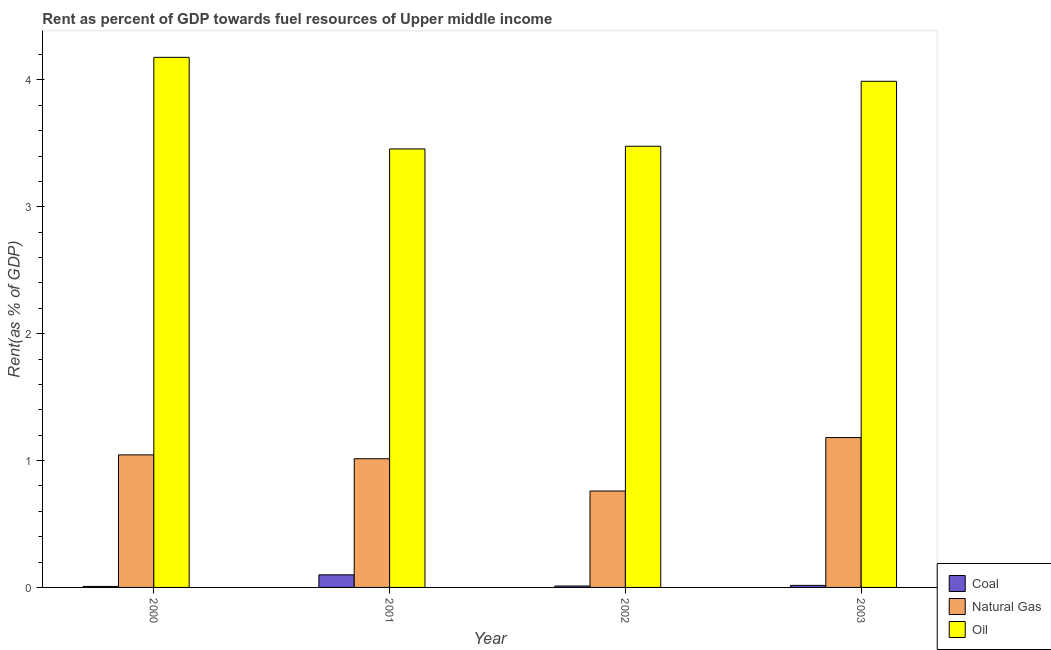How many groups of bars are there?
Ensure brevity in your answer.  4. Are the number of bars per tick equal to the number of legend labels?
Provide a short and direct response. Yes. Are the number of bars on each tick of the X-axis equal?
Provide a succinct answer. Yes. How many bars are there on the 1st tick from the left?
Your answer should be compact. 3. How many bars are there on the 1st tick from the right?
Make the answer very short. 3. What is the label of the 2nd group of bars from the left?
Provide a short and direct response. 2001. In how many cases, is the number of bars for a given year not equal to the number of legend labels?
Make the answer very short. 0. What is the rent towards coal in 2001?
Give a very brief answer. 0.1. Across all years, what is the maximum rent towards oil?
Your response must be concise. 4.18. Across all years, what is the minimum rent towards oil?
Your response must be concise. 3.46. In which year was the rent towards coal maximum?
Make the answer very short. 2001. What is the total rent towards oil in the graph?
Offer a terse response. 15.1. What is the difference between the rent towards oil in 2001 and that in 2003?
Your answer should be very brief. -0.53. What is the difference between the rent towards natural gas in 2003 and the rent towards oil in 2002?
Ensure brevity in your answer.  0.42. What is the average rent towards coal per year?
Give a very brief answer. 0.03. In the year 2002, what is the difference between the rent towards natural gas and rent towards coal?
Your answer should be very brief. 0. What is the ratio of the rent towards coal in 2000 to that in 2002?
Offer a terse response. 0.72. What is the difference between the highest and the second highest rent towards oil?
Your response must be concise. 0.19. What is the difference between the highest and the lowest rent towards oil?
Offer a very short reply. 0.72. What does the 1st bar from the left in 2002 represents?
Keep it short and to the point. Coal. What does the 1st bar from the right in 2000 represents?
Give a very brief answer. Oil. Is it the case that in every year, the sum of the rent towards coal and rent towards natural gas is greater than the rent towards oil?
Provide a succinct answer. No. Are all the bars in the graph horizontal?
Make the answer very short. No. How many years are there in the graph?
Keep it short and to the point. 4. What is the difference between two consecutive major ticks on the Y-axis?
Offer a very short reply. 1. Are the values on the major ticks of Y-axis written in scientific E-notation?
Provide a succinct answer. No. Does the graph contain any zero values?
Offer a terse response. No. Does the graph contain grids?
Offer a very short reply. No. Where does the legend appear in the graph?
Ensure brevity in your answer.  Bottom right. How are the legend labels stacked?
Your response must be concise. Vertical. What is the title of the graph?
Provide a short and direct response. Rent as percent of GDP towards fuel resources of Upper middle income. Does "Food" appear as one of the legend labels in the graph?
Your answer should be very brief. No. What is the label or title of the X-axis?
Provide a short and direct response. Year. What is the label or title of the Y-axis?
Give a very brief answer. Rent(as % of GDP). What is the Rent(as % of GDP) of Coal in 2000?
Provide a short and direct response. 0.01. What is the Rent(as % of GDP) of Natural Gas in 2000?
Keep it short and to the point. 1.04. What is the Rent(as % of GDP) of Oil in 2000?
Your response must be concise. 4.18. What is the Rent(as % of GDP) in Coal in 2001?
Your answer should be compact. 0.1. What is the Rent(as % of GDP) of Natural Gas in 2001?
Provide a short and direct response. 1.01. What is the Rent(as % of GDP) in Oil in 2001?
Offer a very short reply. 3.46. What is the Rent(as % of GDP) of Coal in 2002?
Your answer should be very brief. 0.01. What is the Rent(as % of GDP) of Natural Gas in 2002?
Keep it short and to the point. 0.76. What is the Rent(as % of GDP) in Oil in 2002?
Offer a terse response. 3.48. What is the Rent(as % of GDP) in Coal in 2003?
Provide a succinct answer. 0.02. What is the Rent(as % of GDP) in Natural Gas in 2003?
Give a very brief answer. 1.18. What is the Rent(as % of GDP) in Oil in 2003?
Provide a short and direct response. 3.99. Across all years, what is the maximum Rent(as % of GDP) of Coal?
Provide a succinct answer. 0.1. Across all years, what is the maximum Rent(as % of GDP) of Natural Gas?
Your response must be concise. 1.18. Across all years, what is the maximum Rent(as % of GDP) in Oil?
Your answer should be compact. 4.18. Across all years, what is the minimum Rent(as % of GDP) of Coal?
Provide a short and direct response. 0.01. Across all years, what is the minimum Rent(as % of GDP) of Natural Gas?
Make the answer very short. 0.76. Across all years, what is the minimum Rent(as % of GDP) of Oil?
Give a very brief answer. 3.46. What is the total Rent(as % of GDP) of Coal in the graph?
Your answer should be very brief. 0.13. What is the total Rent(as % of GDP) in Natural Gas in the graph?
Provide a short and direct response. 4. What is the total Rent(as % of GDP) of Oil in the graph?
Your response must be concise. 15.1. What is the difference between the Rent(as % of GDP) of Coal in 2000 and that in 2001?
Offer a very short reply. -0.09. What is the difference between the Rent(as % of GDP) of Natural Gas in 2000 and that in 2001?
Give a very brief answer. 0.03. What is the difference between the Rent(as % of GDP) in Oil in 2000 and that in 2001?
Your answer should be very brief. 0.72. What is the difference between the Rent(as % of GDP) in Coal in 2000 and that in 2002?
Make the answer very short. -0. What is the difference between the Rent(as % of GDP) in Natural Gas in 2000 and that in 2002?
Your answer should be compact. 0.28. What is the difference between the Rent(as % of GDP) in Oil in 2000 and that in 2002?
Offer a very short reply. 0.7. What is the difference between the Rent(as % of GDP) of Coal in 2000 and that in 2003?
Offer a very short reply. -0.01. What is the difference between the Rent(as % of GDP) of Natural Gas in 2000 and that in 2003?
Offer a very short reply. -0.14. What is the difference between the Rent(as % of GDP) of Oil in 2000 and that in 2003?
Provide a succinct answer. 0.19. What is the difference between the Rent(as % of GDP) of Coal in 2001 and that in 2002?
Offer a very short reply. 0.09. What is the difference between the Rent(as % of GDP) in Natural Gas in 2001 and that in 2002?
Your response must be concise. 0.25. What is the difference between the Rent(as % of GDP) of Oil in 2001 and that in 2002?
Ensure brevity in your answer.  -0.02. What is the difference between the Rent(as % of GDP) in Coal in 2001 and that in 2003?
Keep it short and to the point. 0.08. What is the difference between the Rent(as % of GDP) of Natural Gas in 2001 and that in 2003?
Provide a short and direct response. -0.17. What is the difference between the Rent(as % of GDP) in Oil in 2001 and that in 2003?
Your answer should be compact. -0.53. What is the difference between the Rent(as % of GDP) of Coal in 2002 and that in 2003?
Offer a very short reply. -0.01. What is the difference between the Rent(as % of GDP) of Natural Gas in 2002 and that in 2003?
Offer a very short reply. -0.42. What is the difference between the Rent(as % of GDP) of Oil in 2002 and that in 2003?
Keep it short and to the point. -0.51. What is the difference between the Rent(as % of GDP) in Coal in 2000 and the Rent(as % of GDP) in Natural Gas in 2001?
Your answer should be very brief. -1.01. What is the difference between the Rent(as % of GDP) of Coal in 2000 and the Rent(as % of GDP) of Oil in 2001?
Your answer should be very brief. -3.45. What is the difference between the Rent(as % of GDP) in Natural Gas in 2000 and the Rent(as % of GDP) in Oil in 2001?
Provide a succinct answer. -2.41. What is the difference between the Rent(as % of GDP) of Coal in 2000 and the Rent(as % of GDP) of Natural Gas in 2002?
Keep it short and to the point. -0.75. What is the difference between the Rent(as % of GDP) of Coal in 2000 and the Rent(as % of GDP) of Oil in 2002?
Provide a short and direct response. -3.47. What is the difference between the Rent(as % of GDP) of Natural Gas in 2000 and the Rent(as % of GDP) of Oil in 2002?
Your answer should be compact. -2.43. What is the difference between the Rent(as % of GDP) of Coal in 2000 and the Rent(as % of GDP) of Natural Gas in 2003?
Keep it short and to the point. -1.17. What is the difference between the Rent(as % of GDP) of Coal in 2000 and the Rent(as % of GDP) of Oil in 2003?
Make the answer very short. -3.98. What is the difference between the Rent(as % of GDP) of Natural Gas in 2000 and the Rent(as % of GDP) of Oil in 2003?
Offer a terse response. -2.94. What is the difference between the Rent(as % of GDP) of Coal in 2001 and the Rent(as % of GDP) of Natural Gas in 2002?
Keep it short and to the point. -0.66. What is the difference between the Rent(as % of GDP) of Coal in 2001 and the Rent(as % of GDP) of Oil in 2002?
Offer a terse response. -3.38. What is the difference between the Rent(as % of GDP) of Natural Gas in 2001 and the Rent(as % of GDP) of Oil in 2002?
Your answer should be compact. -2.46. What is the difference between the Rent(as % of GDP) in Coal in 2001 and the Rent(as % of GDP) in Natural Gas in 2003?
Keep it short and to the point. -1.08. What is the difference between the Rent(as % of GDP) of Coal in 2001 and the Rent(as % of GDP) of Oil in 2003?
Keep it short and to the point. -3.89. What is the difference between the Rent(as % of GDP) of Natural Gas in 2001 and the Rent(as % of GDP) of Oil in 2003?
Offer a very short reply. -2.98. What is the difference between the Rent(as % of GDP) of Coal in 2002 and the Rent(as % of GDP) of Natural Gas in 2003?
Keep it short and to the point. -1.17. What is the difference between the Rent(as % of GDP) of Coal in 2002 and the Rent(as % of GDP) of Oil in 2003?
Keep it short and to the point. -3.98. What is the difference between the Rent(as % of GDP) of Natural Gas in 2002 and the Rent(as % of GDP) of Oil in 2003?
Offer a very short reply. -3.23. What is the average Rent(as % of GDP) in Coal per year?
Make the answer very short. 0.03. What is the average Rent(as % of GDP) of Oil per year?
Make the answer very short. 3.78. In the year 2000, what is the difference between the Rent(as % of GDP) of Coal and Rent(as % of GDP) of Natural Gas?
Provide a succinct answer. -1.04. In the year 2000, what is the difference between the Rent(as % of GDP) in Coal and Rent(as % of GDP) in Oil?
Your answer should be very brief. -4.17. In the year 2000, what is the difference between the Rent(as % of GDP) in Natural Gas and Rent(as % of GDP) in Oil?
Your answer should be very brief. -3.13. In the year 2001, what is the difference between the Rent(as % of GDP) in Coal and Rent(as % of GDP) in Natural Gas?
Give a very brief answer. -0.92. In the year 2001, what is the difference between the Rent(as % of GDP) in Coal and Rent(as % of GDP) in Oil?
Your answer should be compact. -3.36. In the year 2001, what is the difference between the Rent(as % of GDP) in Natural Gas and Rent(as % of GDP) in Oil?
Make the answer very short. -2.44. In the year 2002, what is the difference between the Rent(as % of GDP) of Coal and Rent(as % of GDP) of Natural Gas?
Your answer should be very brief. -0.75. In the year 2002, what is the difference between the Rent(as % of GDP) of Coal and Rent(as % of GDP) of Oil?
Give a very brief answer. -3.47. In the year 2002, what is the difference between the Rent(as % of GDP) of Natural Gas and Rent(as % of GDP) of Oil?
Make the answer very short. -2.72. In the year 2003, what is the difference between the Rent(as % of GDP) of Coal and Rent(as % of GDP) of Natural Gas?
Give a very brief answer. -1.17. In the year 2003, what is the difference between the Rent(as % of GDP) of Coal and Rent(as % of GDP) of Oil?
Your answer should be very brief. -3.97. In the year 2003, what is the difference between the Rent(as % of GDP) in Natural Gas and Rent(as % of GDP) in Oil?
Your answer should be compact. -2.81. What is the ratio of the Rent(as % of GDP) of Coal in 2000 to that in 2001?
Provide a succinct answer. 0.08. What is the ratio of the Rent(as % of GDP) of Natural Gas in 2000 to that in 2001?
Give a very brief answer. 1.03. What is the ratio of the Rent(as % of GDP) in Oil in 2000 to that in 2001?
Provide a succinct answer. 1.21. What is the ratio of the Rent(as % of GDP) of Coal in 2000 to that in 2002?
Your answer should be very brief. 0.72. What is the ratio of the Rent(as % of GDP) in Natural Gas in 2000 to that in 2002?
Make the answer very short. 1.37. What is the ratio of the Rent(as % of GDP) of Oil in 2000 to that in 2002?
Ensure brevity in your answer.  1.2. What is the ratio of the Rent(as % of GDP) of Coal in 2000 to that in 2003?
Provide a short and direct response. 0.49. What is the ratio of the Rent(as % of GDP) in Natural Gas in 2000 to that in 2003?
Make the answer very short. 0.88. What is the ratio of the Rent(as % of GDP) in Oil in 2000 to that in 2003?
Offer a terse response. 1.05. What is the ratio of the Rent(as % of GDP) of Coal in 2001 to that in 2002?
Provide a short and direct response. 8.97. What is the ratio of the Rent(as % of GDP) in Natural Gas in 2001 to that in 2002?
Give a very brief answer. 1.33. What is the ratio of the Rent(as % of GDP) of Oil in 2001 to that in 2002?
Give a very brief answer. 0.99. What is the ratio of the Rent(as % of GDP) in Coal in 2001 to that in 2003?
Provide a short and direct response. 6.14. What is the ratio of the Rent(as % of GDP) in Natural Gas in 2001 to that in 2003?
Provide a succinct answer. 0.86. What is the ratio of the Rent(as % of GDP) of Oil in 2001 to that in 2003?
Keep it short and to the point. 0.87. What is the ratio of the Rent(as % of GDP) in Coal in 2002 to that in 2003?
Ensure brevity in your answer.  0.69. What is the ratio of the Rent(as % of GDP) in Natural Gas in 2002 to that in 2003?
Give a very brief answer. 0.64. What is the ratio of the Rent(as % of GDP) of Oil in 2002 to that in 2003?
Offer a terse response. 0.87. What is the difference between the highest and the second highest Rent(as % of GDP) of Coal?
Keep it short and to the point. 0.08. What is the difference between the highest and the second highest Rent(as % of GDP) of Natural Gas?
Provide a short and direct response. 0.14. What is the difference between the highest and the second highest Rent(as % of GDP) in Oil?
Your answer should be very brief. 0.19. What is the difference between the highest and the lowest Rent(as % of GDP) in Coal?
Give a very brief answer. 0.09. What is the difference between the highest and the lowest Rent(as % of GDP) of Natural Gas?
Offer a terse response. 0.42. What is the difference between the highest and the lowest Rent(as % of GDP) of Oil?
Give a very brief answer. 0.72. 